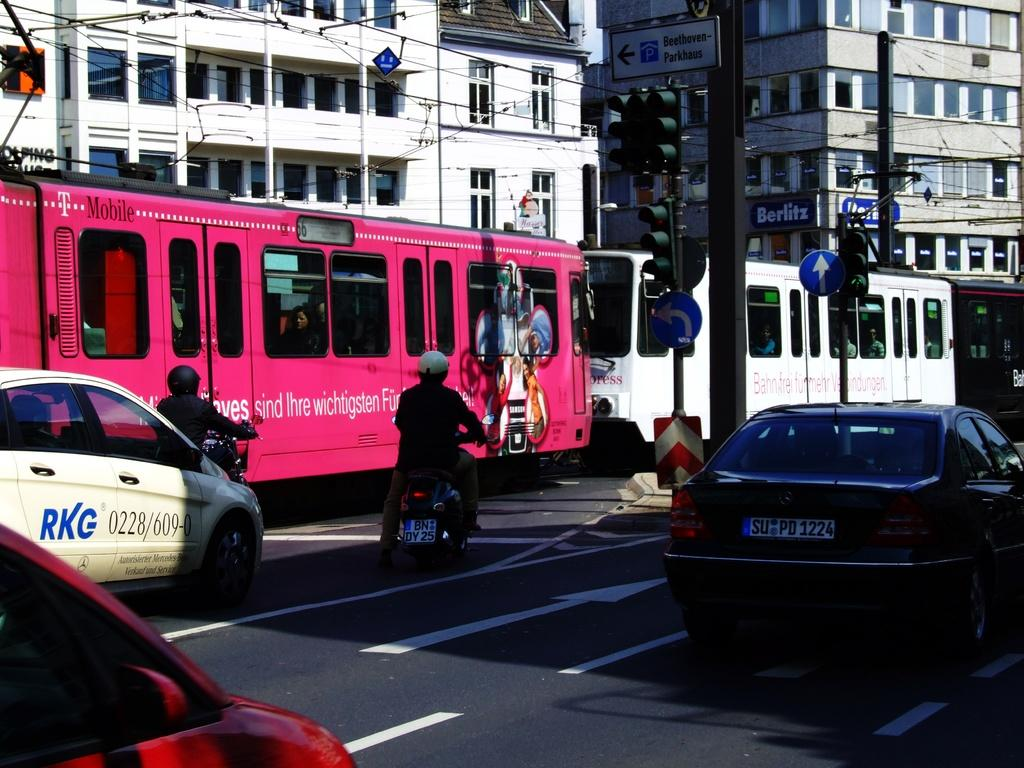What type of vehicle is on the road in the image? There is a train on the road in the image. What other types of vehicles are on the road in the image? There are motor vehicles on the road in the image. Can you describe the train in the image? Unfortunately, the provided facts do not give any details about the train's appearance or characteristics. Where is the basket located in the image? There is no basket present in the image. How does the channel affect the movement of the train in the image? There is no mention of a channel in the provided facts, and therefore it cannot be determined how it would affect the train's movement. 